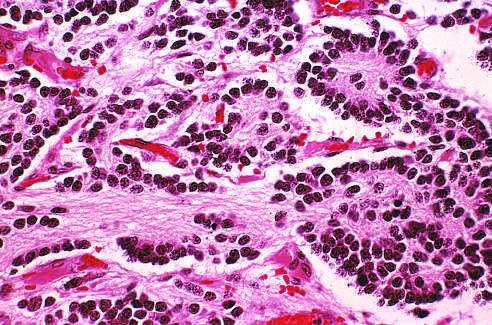s deposition of antibody on endothelium and activation of complement seen in the upper right corner?
Answer the question using a single word or phrase. No 